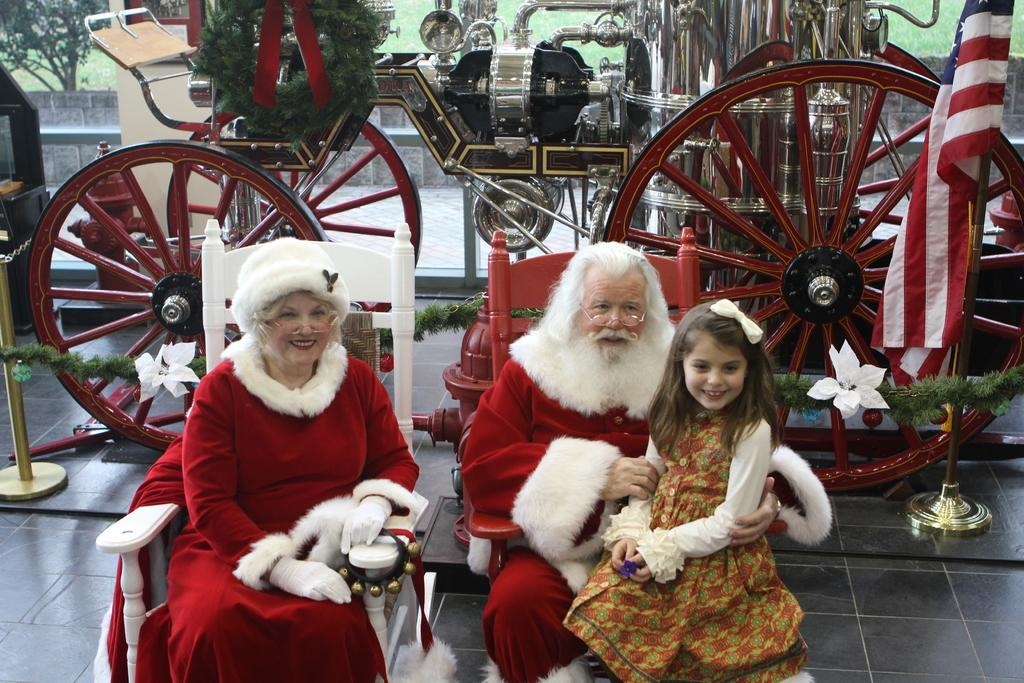What is the theme of the costumes in the image? The man and woman in the image are dressed as Santa Claus. What are the man and woman doing in the image? The man and woman are sitting on chairs. Who else is present in the image? There is a girl in the image. What is the girl doing in the image? The girl is sitting on the man. What object can be seen on the floor in the image? There is a chariot on the floor in the image. What type of servant is shown attending to the man and woman in the image? There is no servant present in the image. What is the base of the chariot made of in the image? The image does not provide information about the base of the chariot. 